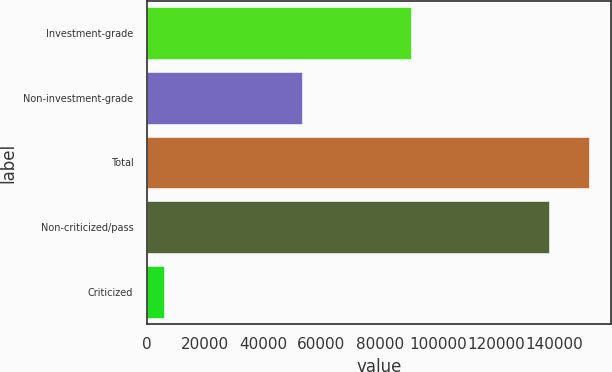Convert chart to OTSL. <chart><loc_0><loc_0><loc_500><loc_500><bar_chart><fcel>Investment-grade<fcel>Non-investment-grade<fcel>Total<fcel>Non-criticized/pass<fcel>Criticized<nl><fcel>90757<fcel>53499<fcel>151923<fcel>138112<fcel>6144<nl></chart> 